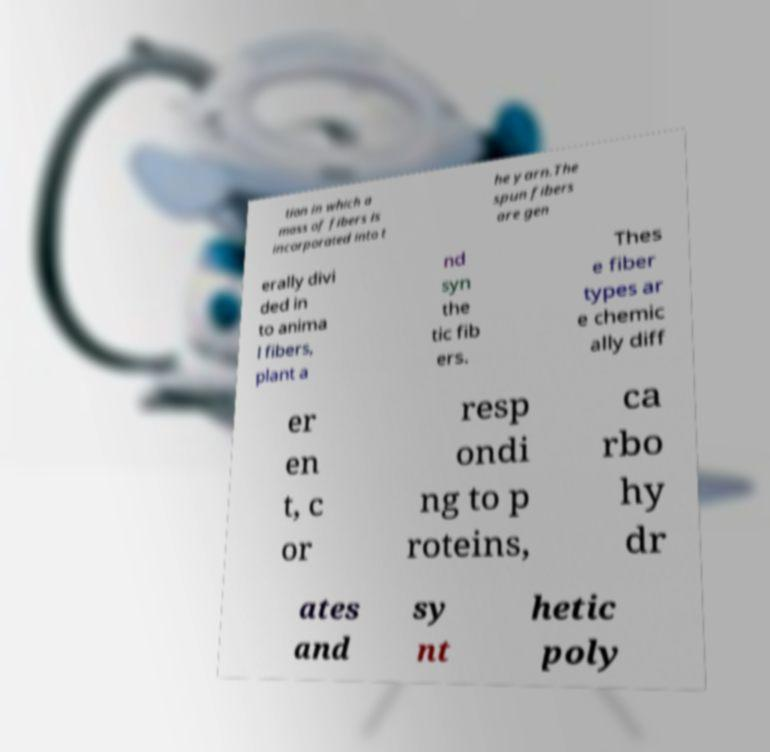Could you extract and type out the text from this image? tion in which a mass of fibers is incorporated into t he yarn.The spun fibers are gen erally divi ded in to anima l fibers, plant a nd syn the tic fib ers. Thes e fiber types ar e chemic ally diff er en t, c or resp ondi ng to p roteins, ca rbo hy dr ates and sy nt hetic poly 